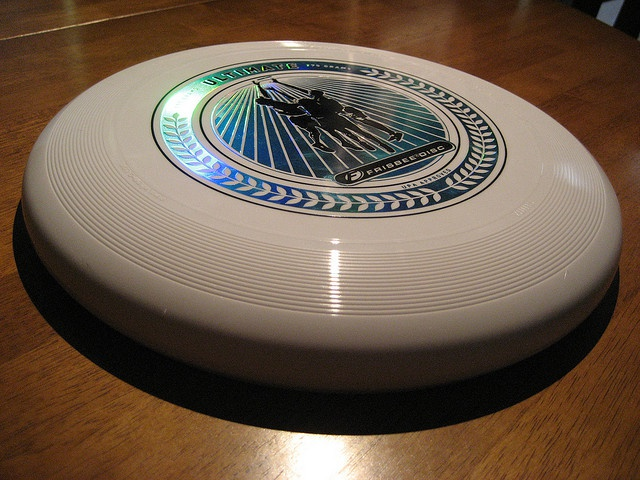Describe the objects in this image and their specific colors. I can see dining table in black, maroon, darkgray, and gray tones and frisbee in black, darkgray, and gray tones in this image. 